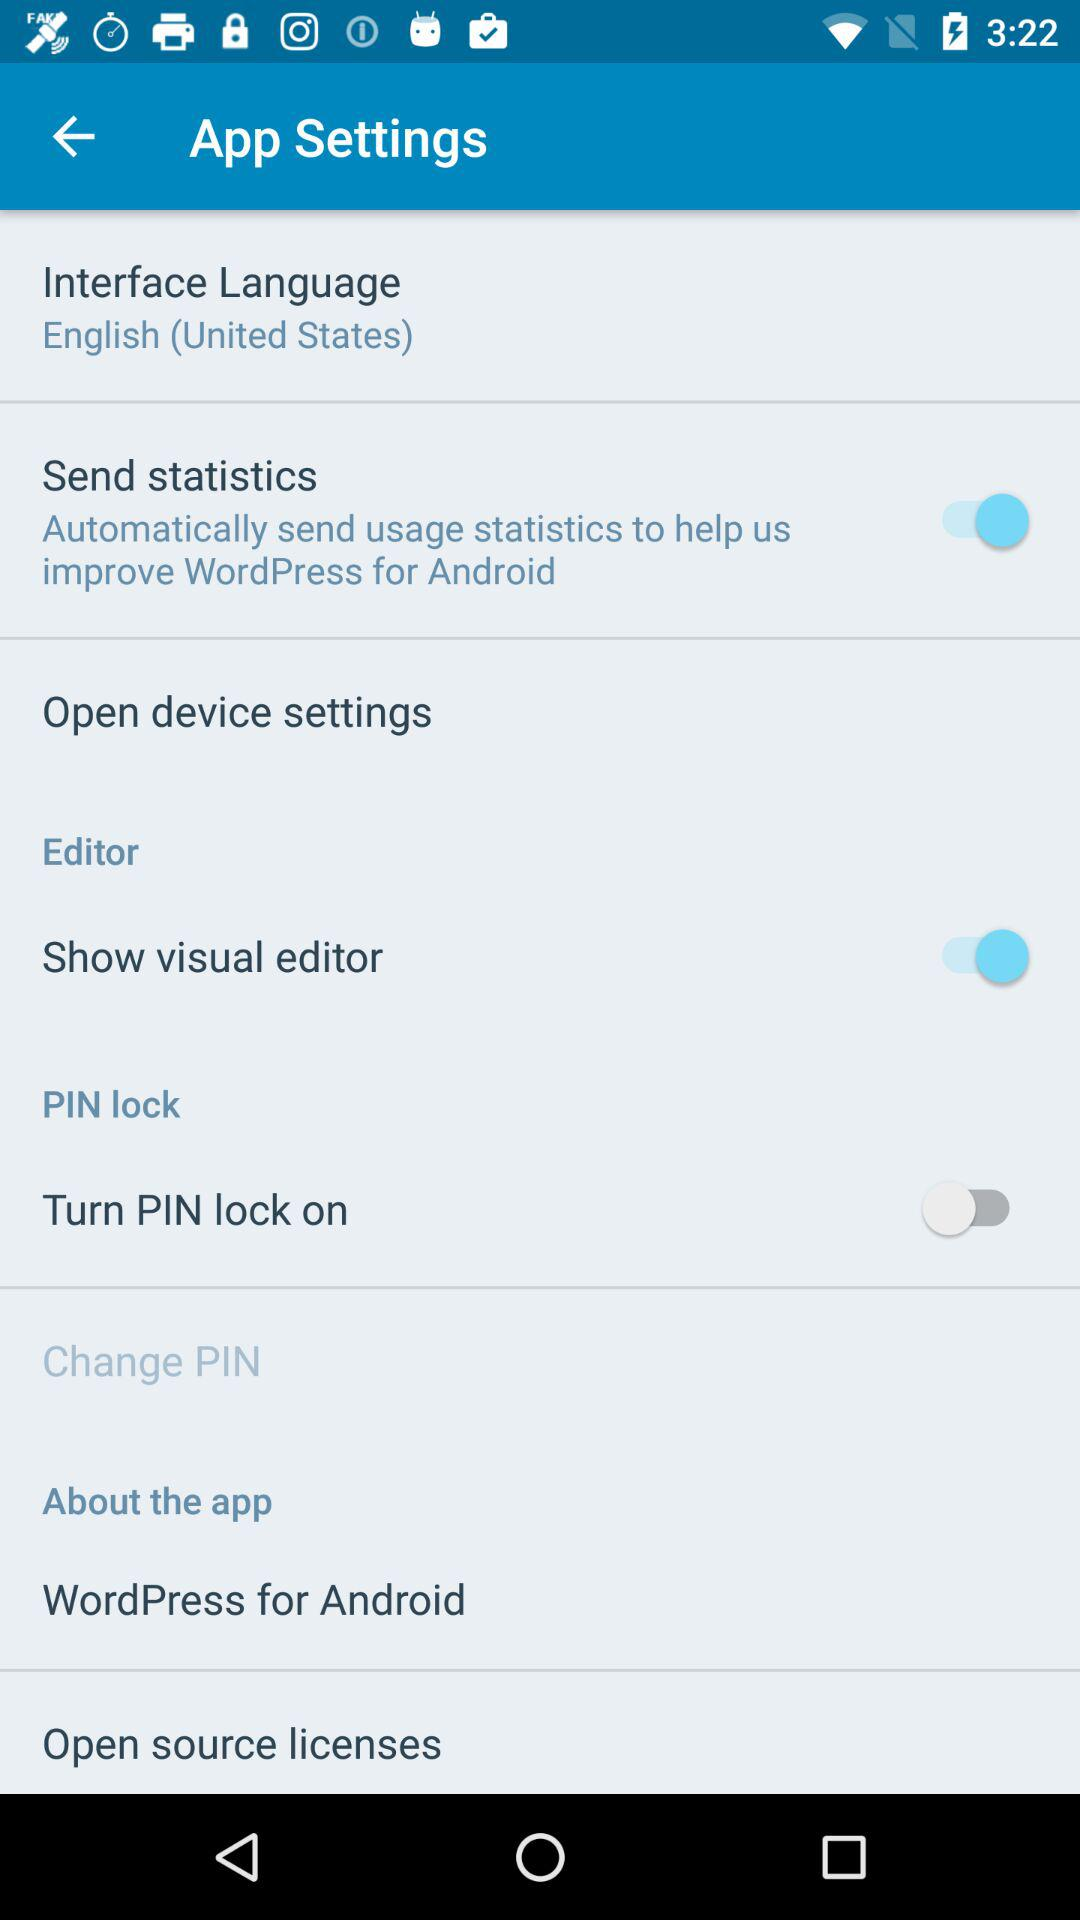What is the status of the show visual editor? The status is on. 